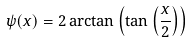Convert formula to latex. <formula><loc_0><loc_0><loc_500><loc_500>\psi ( x ) = 2 \arctan \left ( \tan \left ( \frac { x } { 2 } \right ) \right )</formula> 